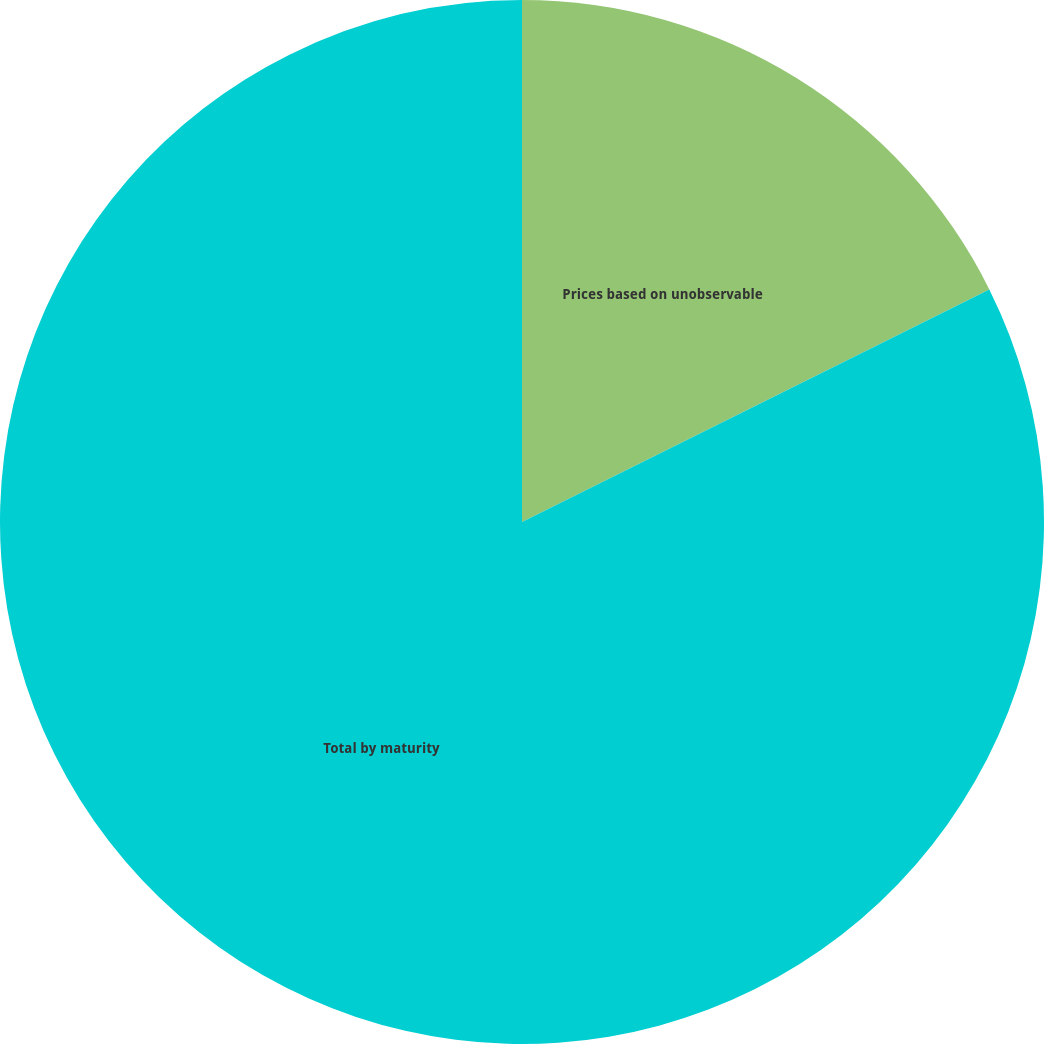Convert chart. <chart><loc_0><loc_0><loc_500><loc_500><pie_chart><fcel>Prices based on unobservable<fcel>Total by maturity<nl><fcel>17.65%<fcel>82.35%<nl></chart> 